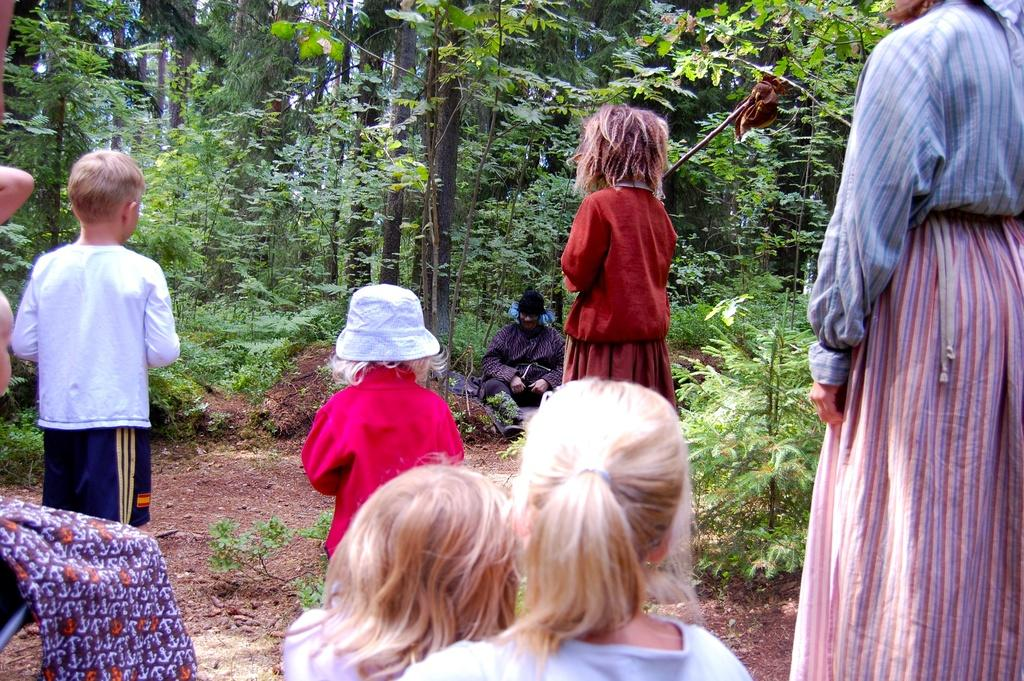Who or what can be seen in the image? There are people in the image. What type of vegetation is present in the image? There are plants and trees in the image. Can you describe the cloth visible in the bottom left side of the image? Yes, there is cloth visible in the bottom left side of the image. What type of ghost is visible in the image? There is no ghost present in the image. Can you describe the sock that the person is wearing in the image? There is no sock visible in the image. 